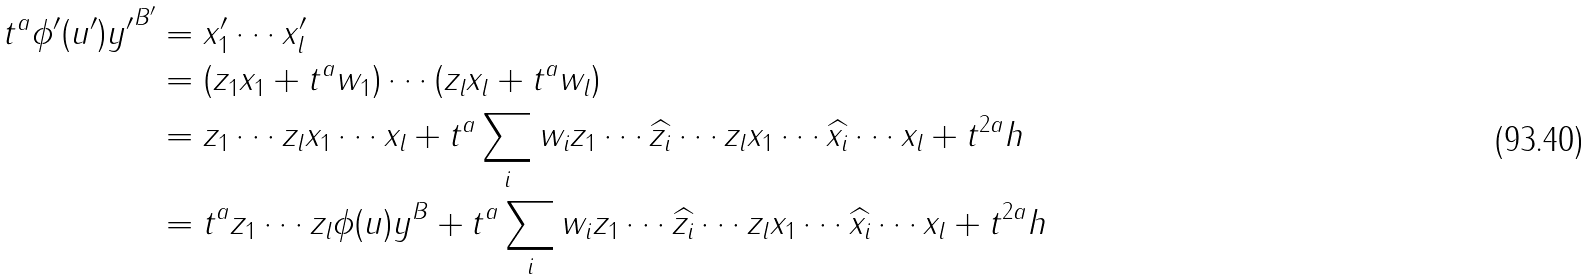<formula> <loc_0><loc_0><loc_500><loc_500>t ^ { a } \phi ^ { \prime } ( u ^ { \prime } ) { y ^ { \prime } } ^ { B ^ { \prime } } & = x ^ { \prime } _ { 1 } \cdots x ^ { \prime } _ { l } \\ & = ( z _ { 1 } x _ { 1 } + t ^ { a } w _ { 1 } ) \cdots ( z _ { l } x _ { l } + t ^ { a } w _ { l } ) \\ & = z _ { 1 } \cdots z _ { l } x _ { 1 } \cdots x _ { l } + t ^ { a } \sum _ { i } w _ { i } z _ { 1 } \cdots \widehat { z _ { i } } \cdots z _ { l } x _ { 1 } \cdots \widehat { x _ { i } } \cdots x _ { l } + t ^ { 2 a } h \\ & = t ^ { a } z _ { 1 } \cdots z _ { l } \phi ( u ) y ^ { B } + t ^ { a } \sum _ { i } w _ { i } z _ { 1 } \cdots \widehat { z _ { i } } \cdots z _ { l } x _ { 1 } \cdots \widehat { x _ { i } } \cdots x _ { l } + t ^ { 2 a } h \\</formula> 